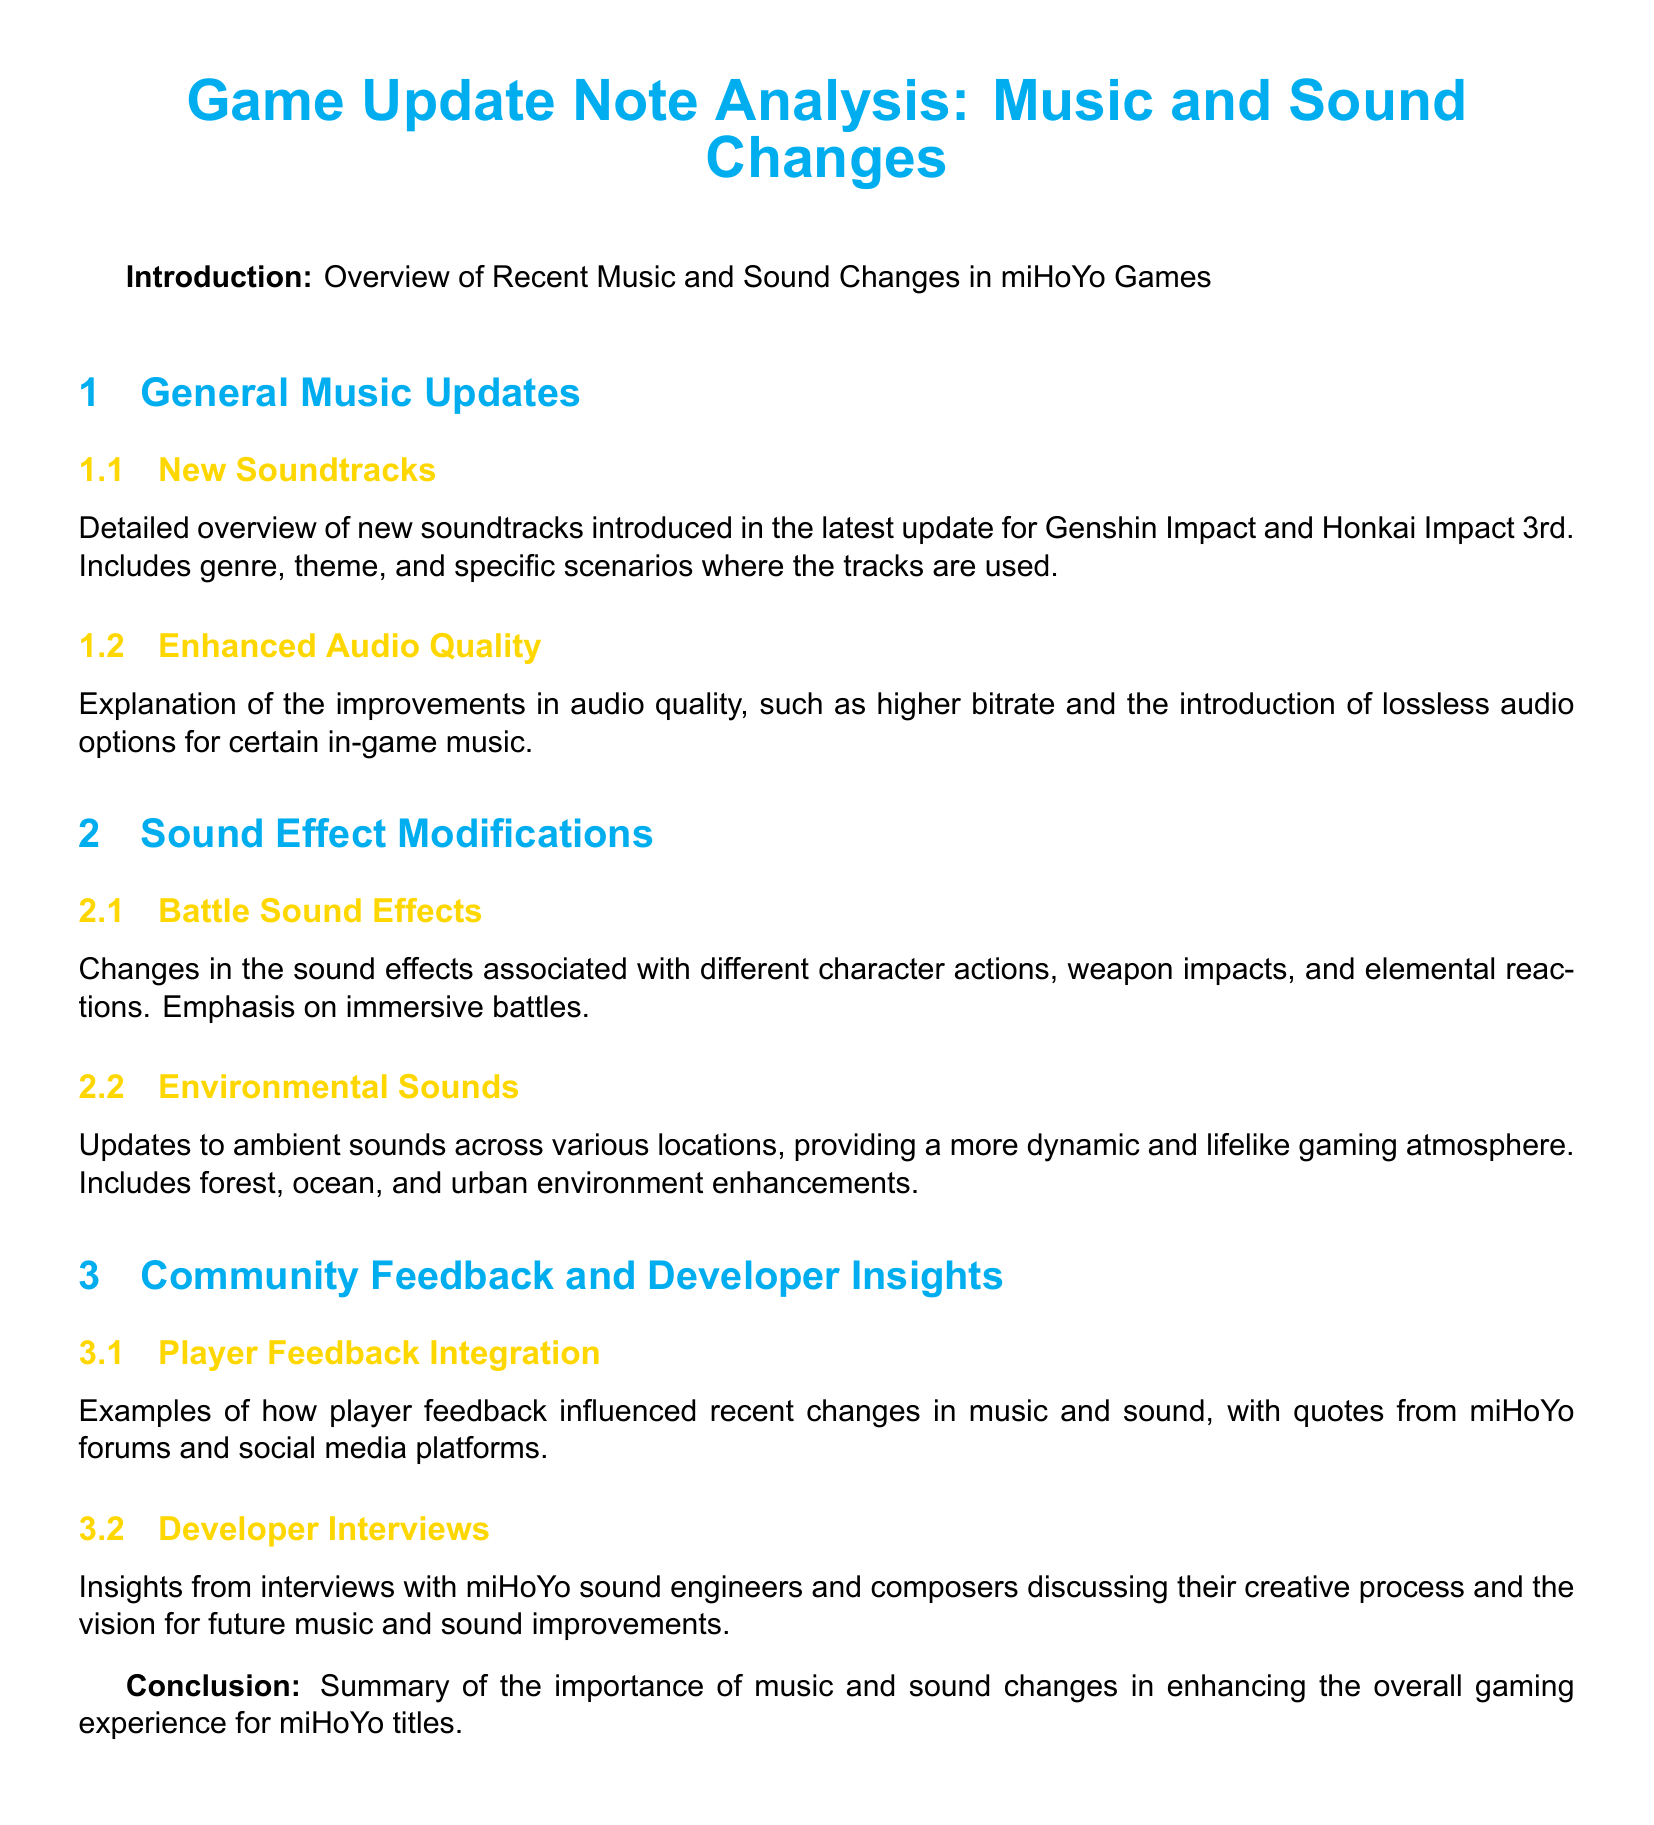What types of updates are discussed in the document? The document discusses general music updates, sound effect modifications, and community feedback and developer insights.
Answer: General music updates, sound effect modifications, community feedback and developer insights How many subcategories are in the General Music Updates section? The General Music Updates section contains two subcategories: New Soundtracks and Enhanced Audio Quality.
Answer: Two Which game is mentioned in relation to new soundtracks? The document specifies that Genshin Impact and Honkai Impact 3rd have new soundtracks introduced in the latest update.
Answer: Genshin Impact and Honkai Impact 3rd What is a specific focus of the Battle Sound Effects modifications? The focus of the Battle Sound Effects modifications is on different character actions, weapon impacts, and elemental reactions for immersive battles.
Answer: Immersive battles What community platforms are referenced for player feedback examples? Player feedback examples are referenced from miHoYo forums and social media platforms in the document.
Answer: MiHoYo forums and social media platforms What type of audio improvements are mentioned? The document mentions enhancements like higher bitrate and the introduction of lossless audio options for certain in-game music.
Answer: Higher bitrate and lossless audio options How does the document summarize the importance of music and sound changes? The conclusion highlights the significance of music and sound changes in enhancing the overall gaming experience for miHoYo titles.
Answer: Enhancing overall gaming experience What narratives or themes are explored in the Developer Interviews section? The Developer Interviews section covers insights into the creative process and vision for future music and sound improvements.
Answer: Creative process and vision for future music and sound improvements 